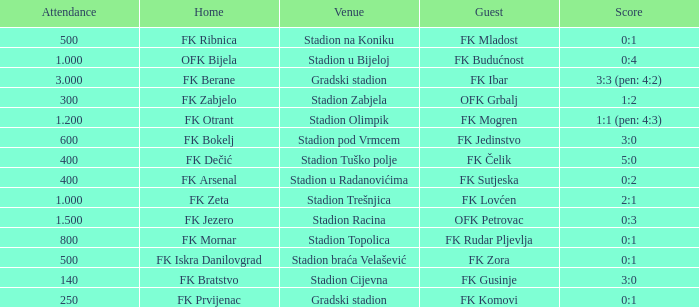What was the attendance of the game that had an away team of FK Mogren? 1.2. 